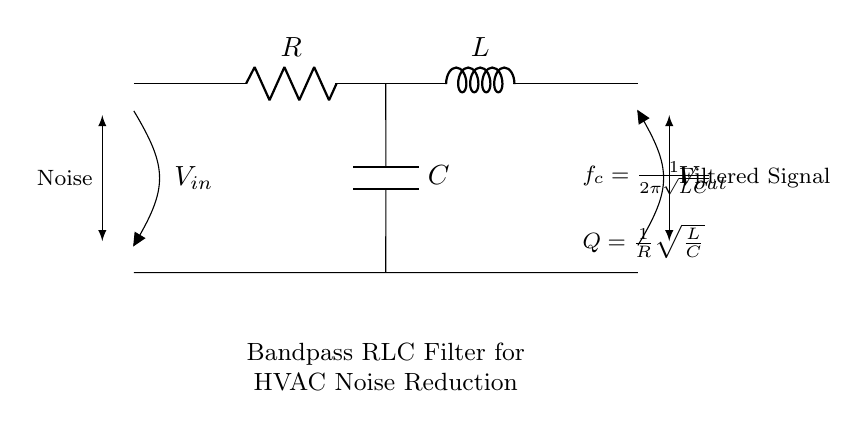What are the three main components in this circuit? The circuit includes a resistor (R), an inductor (L), and a capacitor (C), which are the fundamental elements of a bandpass RLC filter.
Answer: Resistor, Inductor, Capacitor What is the input voltage notation in the circuit? The input voltage is represented as V subscript in, positioned at the left side of the circuit diagram, indicating the voltage source for the filter.
Answer: V in What is the formula for the cutoff frequency f subscript c? The formula for the cutoff frequency is provided in the circuit diagram as f subscript c equals one over the product of two pi and the square root of the inductance and capacitance values, representing the frequency at which the filter effectively operates.
Answer: f c = 1/(2π√(LC)) What is the quality factor (Q) in this circuit? The quality factor, Q, is defined as one over the resistance value multiplied by the square root of the ratio of inductance to capacitance, demonstrating the selectivity of the filter.
Answer: Q = 1/R√(L/C) How does this circuit affect noise in HVAC systems? The bandpass RLC filter is designed to allow specific frequency components to pass through while attenuating others, thereby reducing noise levels in HVAC systems by filtering out undesirable frequencies.
Answer: Reduces noise What is the output voltage notation in the circuit? The output voltage is denoted as V subscript out, located at the right side of the circuit diagram, indicating the voltage across the output of the filter.
Answer: V out 